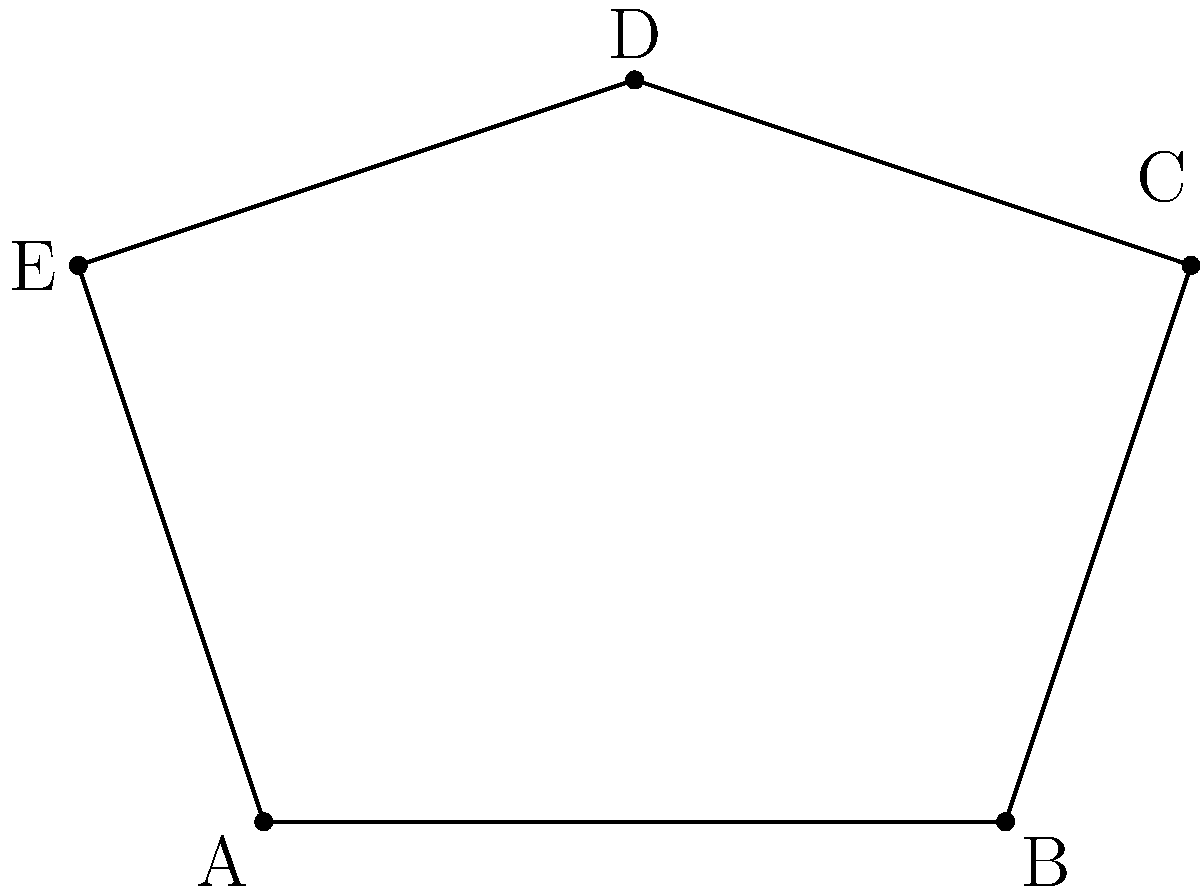In the irregular pentagon ABCDE shown above, what is the sum of its interior angles? Prove that your answer is correct for any pentagon, regardless of its shape. To solve this problem, we'll follow these steps:

1) Recall the formula for the sum of interior angles of a polygon:
   $$(n-2) \times 180°$$
   where $n$ is the number of sides.

2) For a pentagon, $n = 5$. Let's substitute this into our formula:
   $$(5-2) \times 180° = 3 \times 180° = 540°$$

3) To prove this is true for any pentagon, we can use the method of triangulation:

   a) Choose any vertex of the pentagon as a reference point.
   
   b) Draw lines from this vertex to all non-adjacent vertices, dividing the pentagon into triangles.
   
   c) For a pentagon, this will always result in 3 triangles.

4) We know that the sum of angles in a triangle is always 180°.

5) Therefore, the sum of all angles in these 3 triangles is:
   $$3 \times 180° = 540°$$

6) This sum includes all the interior angles of the pentagon, proving that the sum of interior angles in any pentagon is always 540°.

This proof works for any pentagon because the number of triangles formed by this method depends only on the number of sides, not the shape of the polygon.
Answer: 540° 